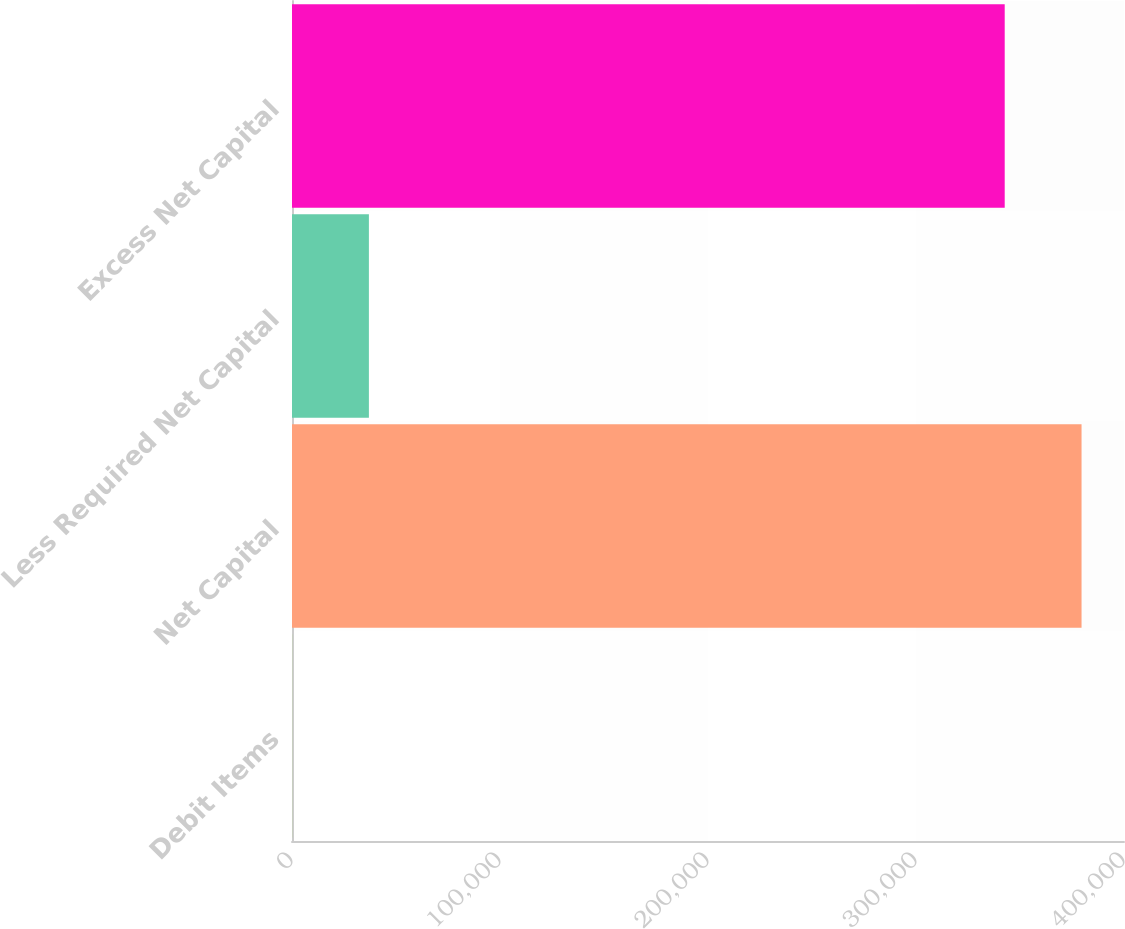Convert chart to OTSL. <chart><loc_0><loc_0><loc_500><loc_500><bar_chart><fcel>Debit Items<fcel>Net Capital<fcel>Less Required Net Capital<fcel>Excess Net Capital<nl><fcel>27.58<fcel>379592<fcel>36969.1<fcel>342650<nl></chart> 